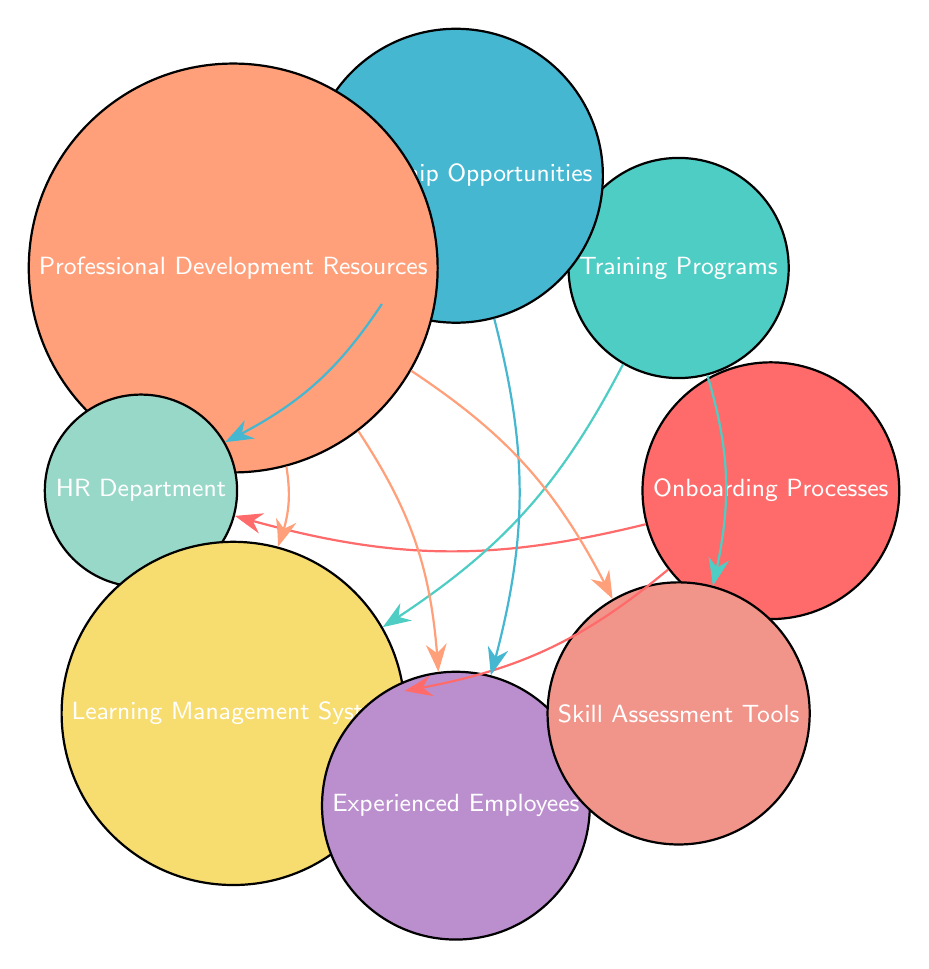What are the nodes in the diagram? The diagram contains eight nodes: Onboarding Processes, Training Programs, Mentorship Opportunities, Professional Development Resources, HR Department, Learning Management System, Experienced Employees, and Skill Assessment Tools.
Answer: Eight nodes How many links are there in total? By counting the arrows connecting the nodes, there are a total of eight links in the diagram.
Answer: Eight links Which two nodes are connected by the link from Onboarding Processes? Onboarding Processes connects to two nodes: HR Department and Learning Management System.
Answer: HR Department and Learning Management System What is the link relationship between Training Programs and Skill Assessment Tools? Training Programs has a direct link to Skill Assessment Tools, indicating that they are related in the context of the diagram.
Answer: Direct link Which node is connected to Mentorship Opportunities that is not an employee or HR-related? The node that connects to Mentorship Opportunities and is not employee or HR-related is Experienced Employees, as it represents a resource rather than a role in HR.
Answer: Experienced Employees How many nodes have direct connections to Learning Management System? The Learning Management System connects to three different nodes: Onboarding Processes, Training Programs, and Professional Development Resources, indicating its key role in the support structure.
Answer: Three nodes Explain the relationships between Professional Development Resources and Skill Assessment Tools. Professional Development Resources has a direct link to Skill Assessment Tools, showing a relationship where Skill Assessment Tools may provide resources or tools used to evaluate skills related to professional development.
Answer: Direct link What is the common node connected to both Mentorship Opportunities and Onboarding Processes? The common node connected to both Mentorship Opportunities and Onboarding Processes is the HR Department, indicating its role in facilitating both processes.
Answer: HR Department What is the primary function of the Learning Management System based on the links shown? The Learning Management System serves as a central hub as it connects with multiple nodes related to onboarding, training, and professional development, indicating its supportive role in learning and training initiatives.
Answer: Central hub 